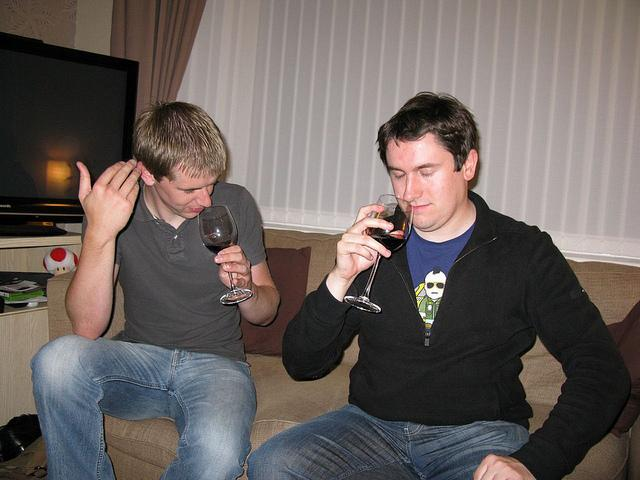Who manufactures the game that the stuffed animal is inspired by? Please explain your reasoning. nintendo. This is from super mario. 